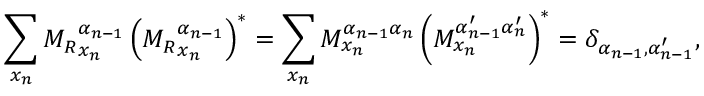Convert formula to latex. <formula><loc_0><loc_0><loc_500><loc_500>\sum _ { x _ { n } } { M _ { R } } _ { x _ { n } } ^ { \alpha _ { n - 1 } } \left ( { M _ { R } } _ { x _ { n } } ^ { \alpha _ { n - 1 } } \right ) ^ { * } = \sum _ { x _ { n } } M _ { x _ { n } } ^ { \alpha _ { n - 1 } \alpha _ { n } } \left ( M _ { x _ { n } } ^ { \alpha _ { n - 1 } ^ { \prime } \alpha _ { n } ^ { \prime } } \right ) ^ { * } = \delta _ { \alpha _ { n - 1 } , \alpha _ { n - 1 } ^ { \prime } } ,</formula> 